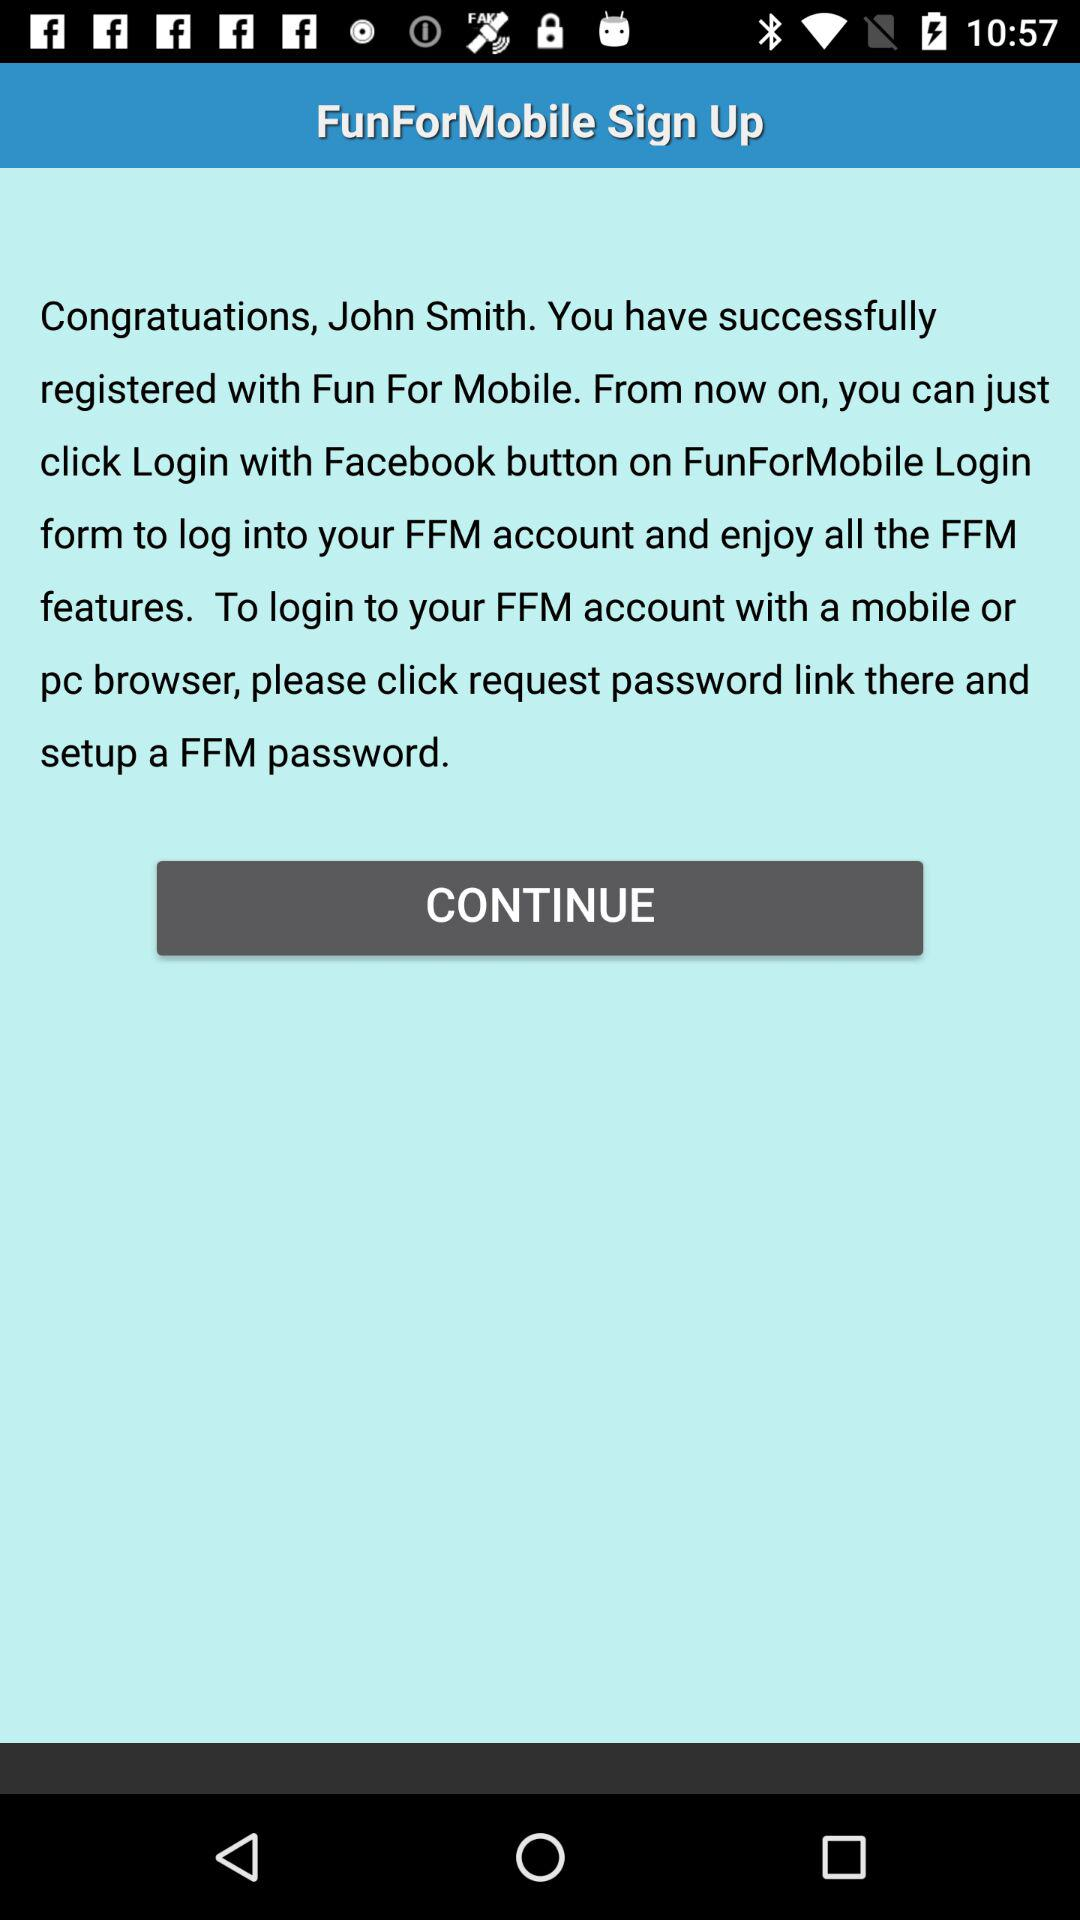What is the user name? The user name is John Smith. 